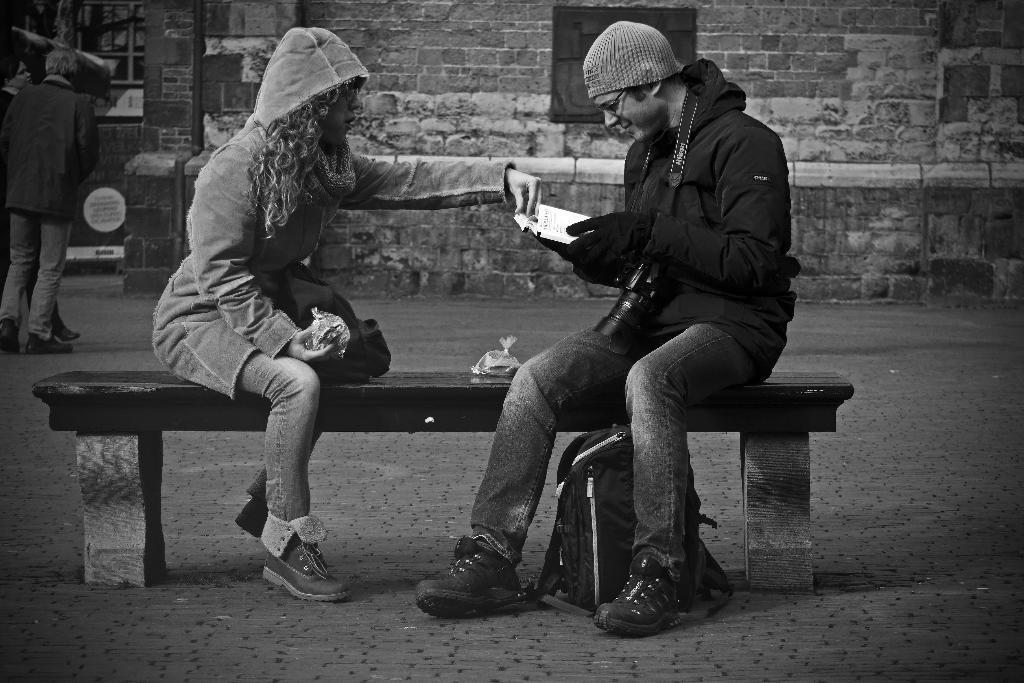In one or two sentences, can you explain what this image depicts? This is a black and white picture. On the background we can see a wall with bricks. We can see two persons walking here. We can see a man and a woman sitting on a bench. This woman is holding a cover in her hand. There is a backpack under the bench. This is man is holding a dairy in his hands. 